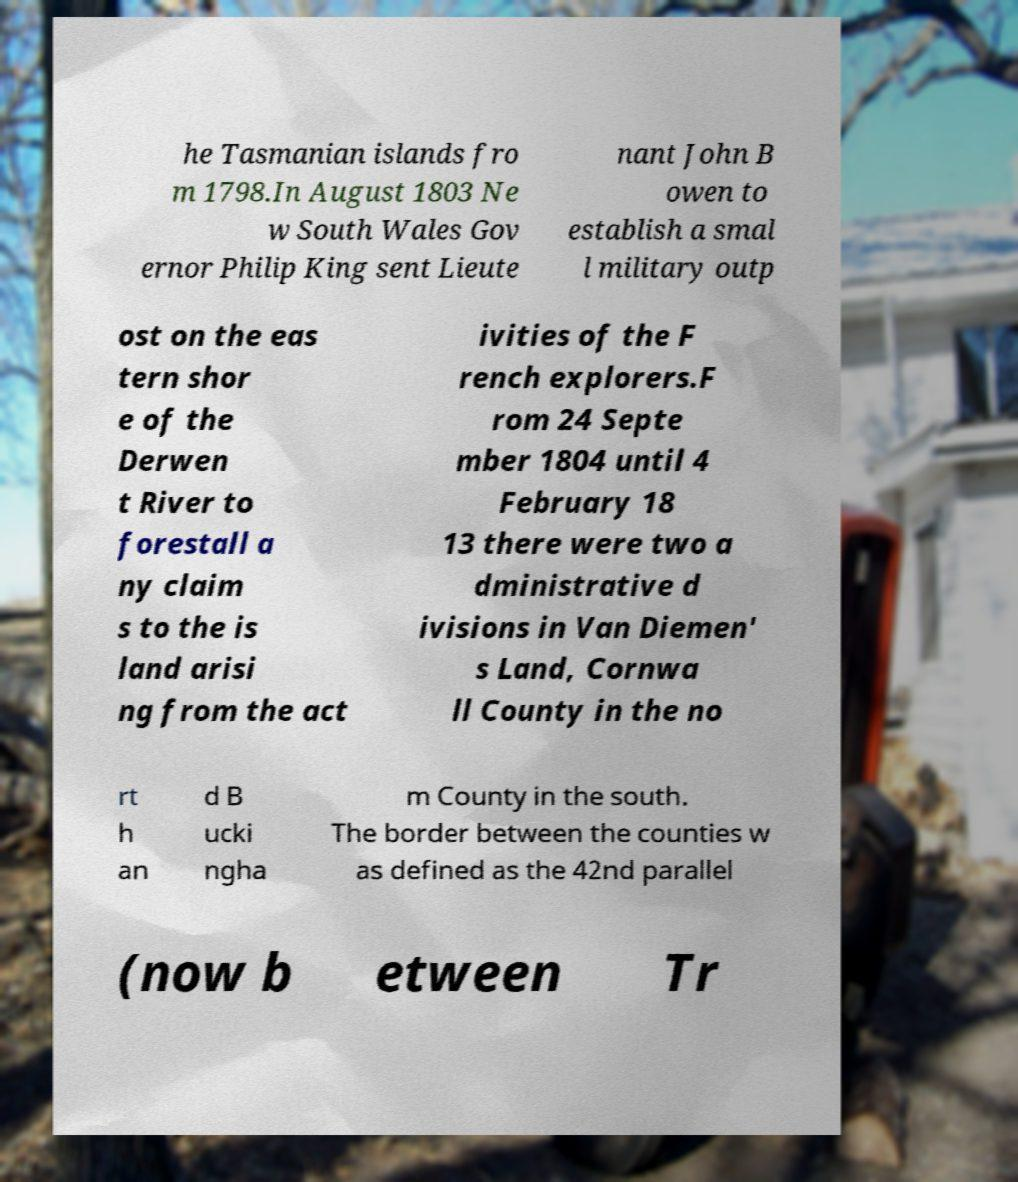There's text embedded in this image that I need extracted. Can you transcribe it verbatim? he Tasmanian islands fro m 1798.In August 1803 Ne w South Wales Gov ernor Philip King sent Lieute nant John B owen to establish a smal l military outp ost on the eas tern shor e of the Derwen t River to forestall a ny claim s to the is land arisi ng from the act ivities of the F rench explorers.F rom 24 Septe mber 1804 until 4 February 18 13 there were two a dministrative d ivisions in Van Diemen' s Land, Cornwa ll County in the no rt h an d B ucki ngha m County in the south. The border between the counties w as defined as the 42nd parallel (now b etween Tr 